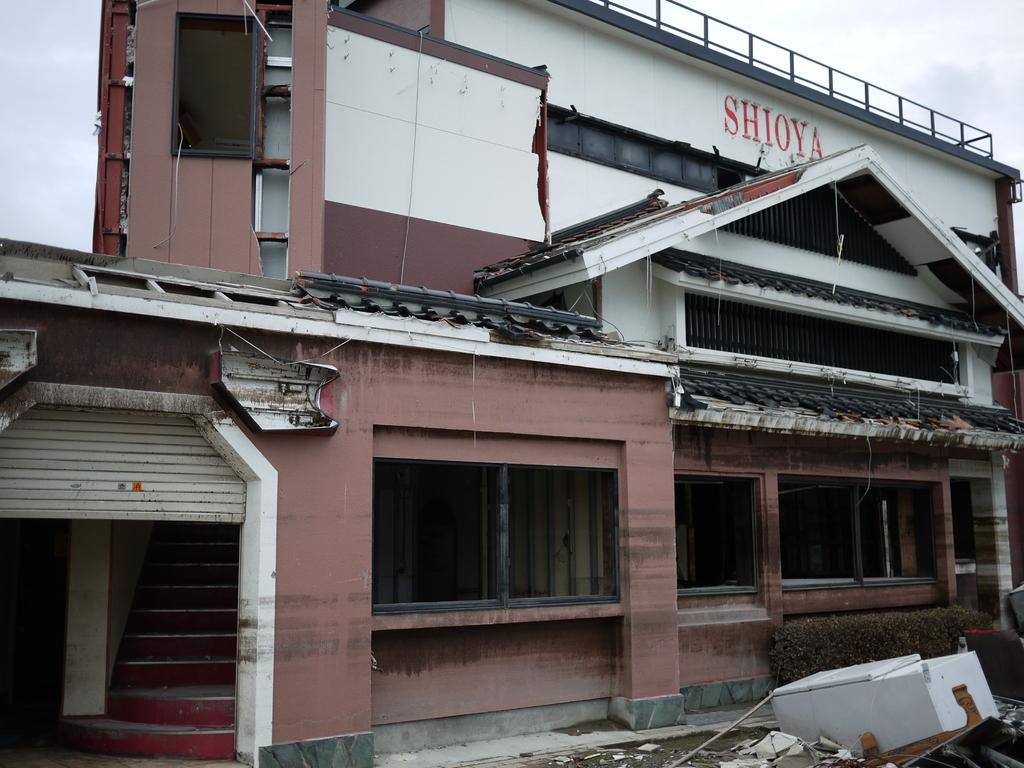What type of structure is present in the image? There is a building in the image. What architectural feature can be seen in the building? There is a staircase in the image. What type of vegetation is present in the image? There are bushes in the image. What type of cooking equipment is present in the image? There are grills in the image. What sign is present in the image? There is a name board in the image. What is visible in the sky in the image? The sky with clouds is visible in the image. What type of waste is present on the floor in the image? There is trash on the floor in the image. How does the steam escape from the shoes in the image? There are no shoes or steam present in the image. What type of form is used to create the building in the image? The building's construction method cannot be determined from the image. 